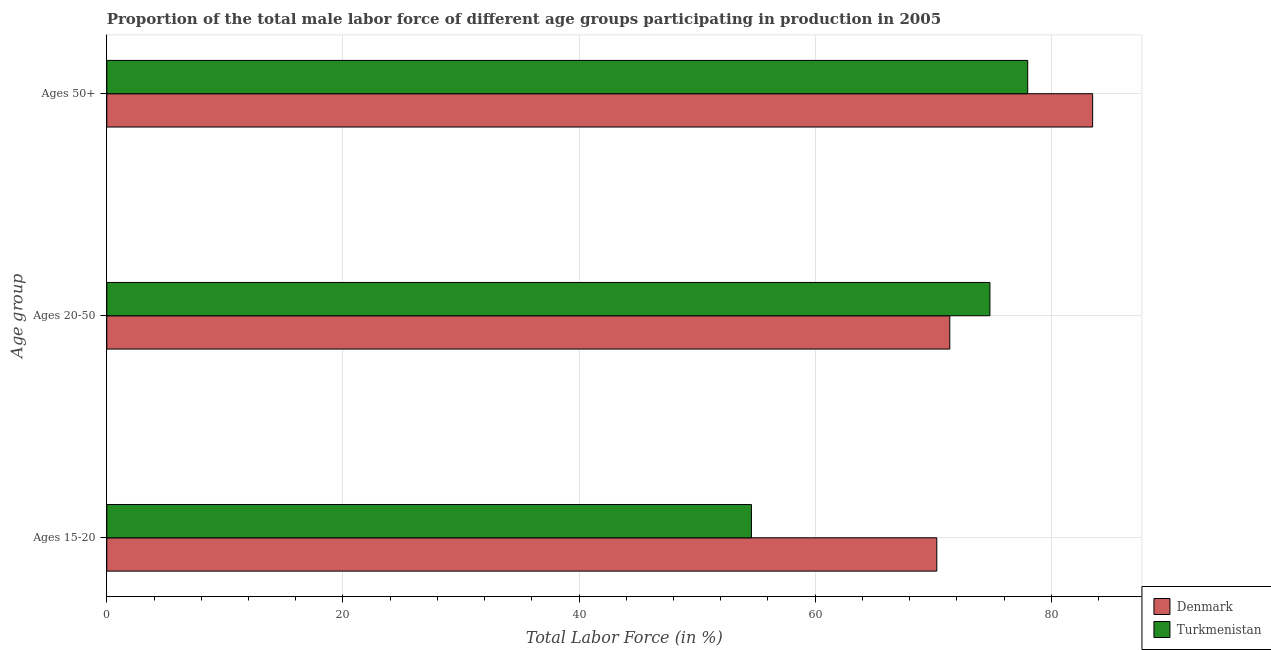How many different coloured bars are there?
Make the answer very short. 2. How many groups of bars are there?
Provide a short and direct response. 3. Are the number of bars per tick equal to the number of legend labels?
Make the answer very short. Yes. How many bars are there on the 1st tick from the top?
Keep it short and to the point. 2. What is the label of the 2nd group of bars from the top?
Offer a terse response. Ages 20-50. What is the percentage of male labor force above age 50 in Denmark?
Offer a terse response. 83.5. Across all countries, what is the maximum percentage of male labor force within the age group 15-20?
Provide a succinct answer. 70.3. Across all countries, what is the minimum percentage of male labor force above age 50?
Your response must be concise. 78. What is the total percentage of male labor force within the age group 20-50 in the graph?
Offer a terse response. 146.2. What is the difference between the percentage of male labor force above age 50 in Denmark and that in Turkmenistan?
Ensure brevity in your answer.  5.5. What is the difference between the percentage of male labor force within the age group 20-50 in Denmark and the percentage of male labor force within the age group 15-20 in Turkmenistan?
Provide a short and direct response. 16.8. What is the average percentage of male labor force within the age group 15-20 per country?
Provide a short and direct response. 62.45. What is the difference between the percentage of male labor force above age 50 and percentage of male labor force within the age group 20-50 in Turkmenistan?
Offer a very short reply. 3.2. What is the ratio of the percentage of male labor force above age 50 in Denmark to that in Turkmenistan?
Keep it short and to the point. 1.07. Is the percentage of male labor force above age 50 in Turkmenistan less than that in Denmark?
Provide a succinct answer. Yes. Is the difference between the percentage of male labor force within the age group 20-50 in Denmark and Turkmenistan greater than the difference between the percentage of male labor force above age 50 in Denmark and Turkmenistan?
Provide a succinct answer. No. What is the difference between the highest and the second highest percentage of male labor force above age 50?
Offer a very short reply. 5.5. In how many countries, is the percentage of male labor force within the age group 15-20 greater than the average percentage of male labor force within the age group 15-20 taken over all countries?
Offer a very short reply. 1. Is the sum of the percentage of male labor force within the age group 15-20 in Turkmenistan and Denmark greater than the maximum percentage of male labor force within the age group 20-50 across all countries?
Provide a short and direct response. Yes. What does the 1st bar from the top in Ages 20-50 represents?
Offer a terse response. Turkmenistan. Is it the case that in every country, the sum of the percentage of male labor force within the age group 15-20 and percentage of male labor force within the age group 20-50 is greater than the percentage of male labor force above age 50?
Your response must be concise. Yes. How many bars are there?
Your answer should be very brief. 6. Are all the bars in the graph horizontal?
Your answer should be compact. Yes. How many countries are there in the graph?
Provide a succinct answer. 2. What is the difference between two consecutive major ticks on the X-axis?
Provide a short and direct response. 20. Are the values on the major ticks of X-axis written in scientific E-notation?
Provide a short and direct response. No. Does the graph contain any zero values?
Your response must be concise. No. Where does the legend appear in the graph?
Give a very brief answer. Bottom right. What is the title of the graph?
Offer a terse response. Proportion of the total male labor force of different age groups participating in production in 2005. What is the label or title of the X-axis?
Offer a terse response. Total Labor Force (in %). What is the label or title of the Y-axis?
Offer a terse response. Age group. What is the Total Labor Force (in %) in Denmark in Ages 15-20?
Keep it short and to the point. 70.3. What is the Total Labor Force (in %) of Turkmenistan in Ages 15-20?
Your response must be concise. 54.6. What is the Total Labor Force (in %) of Denmark in Ages 20-50?
Provide a succinct answer. 71.4. What is the Total Labor Force (in %) in Turkmenistan in Ages 20-50?
Provide a succinct answer. 74.8. What is the Total Labor Force (in %) of Denmark in Ages 50+?
Ensure brevity in your answer.  83.5. What is the Total Labor Force (in %) of Turkmenistan in Ages 50+?
Provide a short and direct response. 78. Across all Age group, what is the maximum Total Labor Force (in %) of Denmark?
Give a very brief answer. 83.5. Across all Age group, what is the minimum Total Labor Force (in %) of Denmark?
Provide a short and direct response. 70.3. Across all Age group, what is the minimum Total Labor Force (in %) of Turkmenistan?
Ensure brevity in your answer.  54.6. What is the total Total Labor Force (in %) in Denmark in the graph?
Offer a very short reply. 225.2. What is the total Total Labor Force (in %) in Turkmenistan in the graph?
Provide a short and direct response. 207.4. What is the difference between the Total Labor Force (in %) of Turkmenistan in Ages 15-20 and that in Ages 20-50?
Your response must be concise. -20.2. What is the difference between the Total Labor Force (in %) in Denmark in Ages 15-20 and that in Ages 50+?
Provide a succinct answer. -13.2. What is the difference between the Total Labor Force (in %) of Turkmenistan in Ages 15-20 and that in Ages 50+?
Offer a terse response. -23.4. What is the difference between the Total Labor Force (in %) of Denmark in Ages 15-20 and the Total Labor Force (in %) of Turkmenistan in Ages 20-50?
Offer a very short reply. -4.5. What is the average Total Labor Force (in %) of Denmark per Age group?
Provide a succinct answer. 75.07. What is the average Total Labor Force (in %) of Turkmenistan per Age group?
Your answer should be compact. 69.13. What is the difference between the Total Labor Force (in %) in Denmark and Total Labor Force (in %) in Turkmenistan in Ages 15-20?
Your answer should be very brief. 15.7. What is the difference between the Total Labor Force (in %) of Denmark and Total Labor Force (in %) of Turkmenistan in Ages 20-50?
Your answer should be compact. -3.4. What is the difference between the Total Labor Force (in %) in Denmark and Total Labor Force (in %) in Turkmenistan in Ages 50+?
Give a very brief answer. 5.5. What is the ratio of the Total Labor Force (in %) in Denmark in Ages 15-20 to that in Ages 20-50?
Make the answer very short. 0.98. What is the ratio of the Total Labor Force (in %) of Turkmenistan in Ages 15-20 to that in Ages 20-50?
Offer a very short reply. 0.73. What is the ratio of the Total Labor Force (in %) of Denmark in Ages 15-20 to that in Ages 50+?
Your answer should be compact. 0.84. What is the ratio of the Total Labor Force (in %) in Denmark in Ages 20-50 to that in Ages 50+?
Your answer should be very brief. 0.86. What is the difference between the highest and the second highest Total Labor Force (in %) of Denmark?
Make the answer very short. 12.1. What is the difference between the highest and the lowest Total Labor Force (in %) of Turkmenistan?
Your answer should be compact. 23.4. 